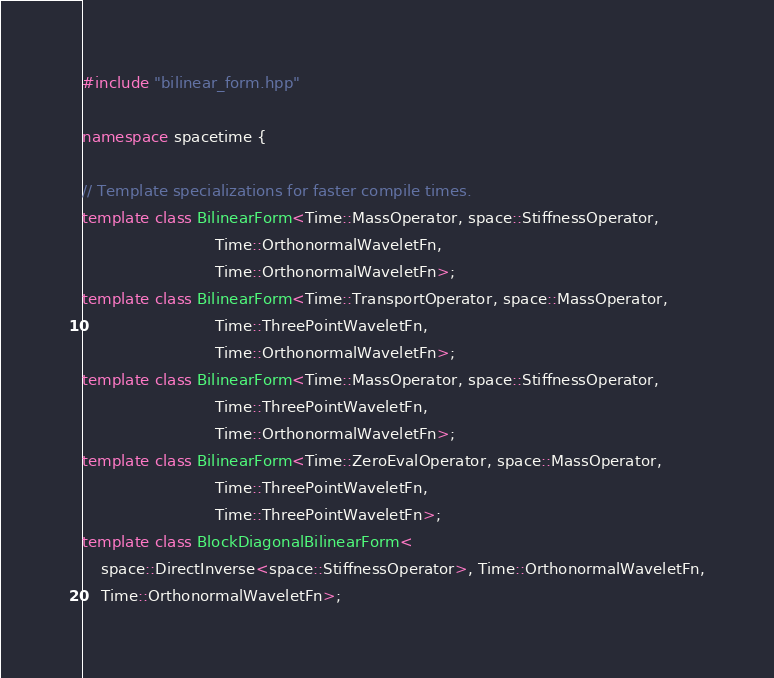Convert code to text. <code><loc_0><loc_0><loc_500><loc_500><_C++_>#include "bilinear_form.hpp"

namespace spacetime {

// Template specializations for faster compile times.
template class BilinearForm<Time::MassOperator, space::StiffnessOperator,
                            Time::OrthonormalWaveletFn,
                            Time::OrthonormalWaveletFn>;
template class BilinearForm<Time::TransportOperator, space::MassOperator,
                            Time::ThreePointWaveletFn,
                            Time::OrthonormalWaveletFn>;
template class BilinearForm<Time::MassOperator, space::StiffnessOperator,
                            Time::ThreePointWaveletFn,
                            Time::OrthonormalWaveletFn>;
template class BilinearForm<Time::ZeroEvalOperator, space::MassOperator,
                            Time::ThreePointWaveletFn,
                            Time::ThreePointWaveletFn>;
template class BlockDiagonalBilinearForm<
    space::DirectInverse<space::StiffnessOperator>, Time::OrthonormalWaveletFn,
    Time::OrthonormalWaveletFn>;</code> 